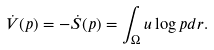<formula> <loc_0><loc_0><loc_500><loc_500>\dot { V } ( p ) = - \dot { S } ( p ) = \int _ { \Omega } { u \log { p } d r } .</formula> 